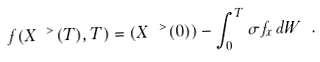<formula> <loc_0><loc_0><loc_500><loc_500>f ( X ^ { \ > } ( T ) , T ) = ( X ^ { \ > } ( 0 ) ) - \int _ { 0 } ^ { T } \sigma f _ { x } \, d W \ .</formula> 